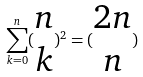Convert formula to latex. <formula><loc_0><loc_0><loc_500><loc_500>\sum _ { k = 0 } ^ { n } ( \begin{matrix} n \\ k \end{matrix} ) ^ { 2 } = ( \begin{matrix} 2 n \\ n \end{matrix} )</formula> 